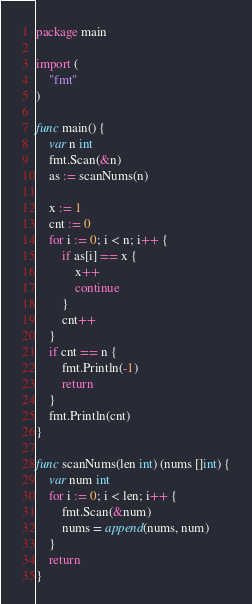<code> <loc_0><loc_0><loc_500><loc_500><_Go_>package main

import (
	"fmt"
)

func main() {
	var n int
	fmt.Scan(&n)
	as := scanNums(n)

	x := 1
	cnt := 0
	for i := 0; i < n; i++ {
		if as[i] == x {
			x++
			continue
		}
		cnt++
	}
	if cnt == n {
		fmt.Println(-1)
		return
	}
	fmt.Println(cnt)
}

func scanNums(len int) (nums []int) {
	var num int
	for i := 0; i < len; i++ {
		fmt.Scan(&num)
		nums = append(nums, num)
	}
	return
}

</code> 